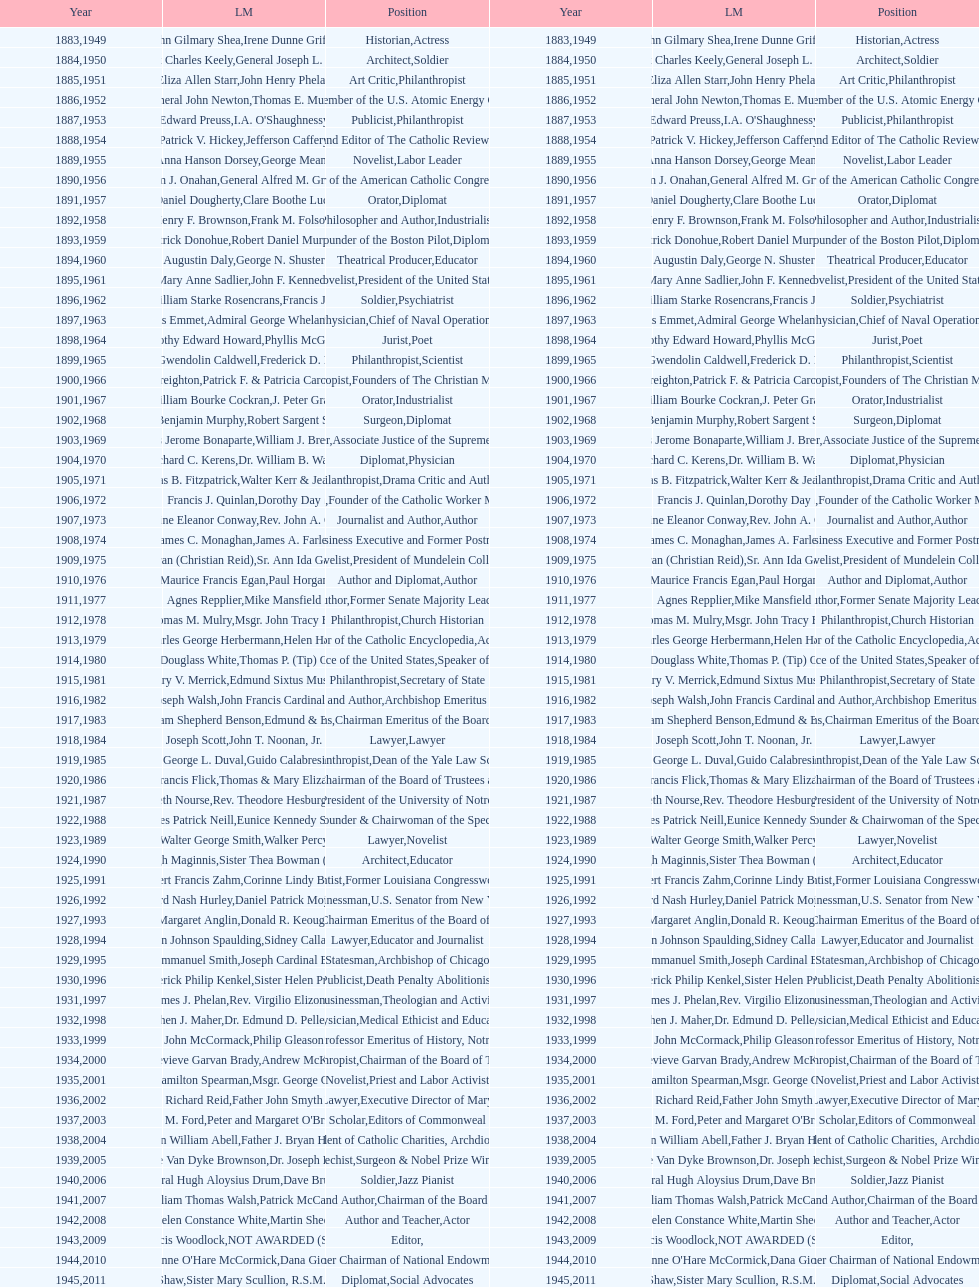Among laetare medalists, how many were involved in philanthropy? 2. 